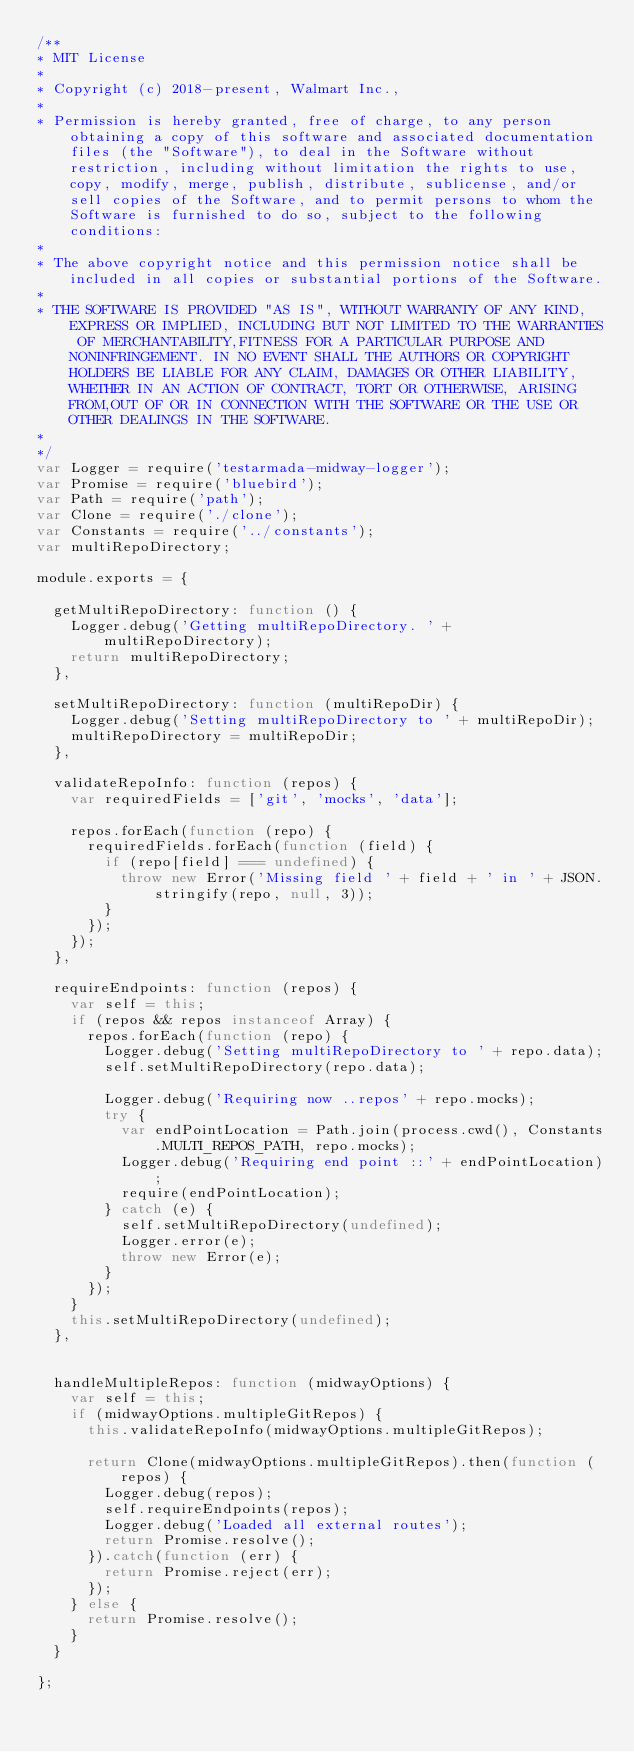Convert code to text. <code><loc_0><loc_0><loc_500><loc_500><_JavaScript_>/**
* MIT License
*
* Copyright (c) 2018-present, Walmart Inc.,
*
* Permission is hereby granted, free of charge, to any person obtaining a copy of this software and associated documentation files (the "Software"), to deal in the Software without restriction, including without limitation the rights to use, copy, modify, merge, publish, distribute, sublicense, and/or sell copies of the Software, and to permit persons to whom the Software is furnished to do so, subject to the following conditions:
*
* The above copyright notice and this permission notice shall be included in all copies or substantial portions of the Software.
*
* THE SOFTWARE IS PROVIDED "AS IS", WITHOUT WARRANTY OF ANY KIND, EXPRESS OR IMPLIED, INCLUDING BUT NOT LIMITED TO THE WARRANTIES OF MERCHANTABILITY,FITNESS FOR A PARTICULAR PURPOSE AND NONINFRINGEMENT. IN NO EVENT SHALL THE AUTHORS OR COPYRIGHT HOLDERS BE LIABLE FOR ANY CLAIM, DAMAGES OR OTHER LIABILITY, WHETHER IN AN ACTION OF CONTRACT, TORT OR OTHERWISE, ARISING FROM,OUT OF OR IN CONNECTION WITH THE SOFTWARE OR THE USE OR OTHER DEALINGS IN THE SOFTWARE.
*
*/
var Logger = require('testarmada-midway-logger');
var Promise = require('bluebird');
var Path = require('path');
var Clone = require('./clone');
var Constants = require('../constants');
var multiRepoDirectory;

module.exports = {

  getMultiRepoDirectory: function () {
    Logger.debug('Getting multiRepoDirectory. ' + multiRepoDirectory);
    return multiRepoDirectory;
  },

  setMultiRepoDirectory: function (multiRepoDir) {
    Logger.debug('Setting multiRepoDirectory to ' + multiRepoDir);
    multiRepoDirectory = multiRepoDir;
  },

  validateRepoInfo: function (repos) {
    var requiredFields = ['git', 'mocks', 'data'];

    repos.forEach(function (repo) {
      requiredFields.forEach(function (field) {
        if (repo[field] === undefined) {
          throw new Error('Missing field ' + field + ' in ' + JSON.stringify(repo, null, 3));
        }
      });
    });
  },

  requireEndpoints: function (repos) {
    var self = this;
    if (repos && repos instanceof Array) {
      repos.forEach(function (repo) {
        Logger.debug('Setting multiRepoDirectory to ' + repo.data);
        self.setMultiRepoDirectory(repo.data);

        Logger.debug('Requiring now ..repos' + repo.mocks);
        try {
          var endPointLocation = Path.join(process.cwd(), Constants.MULTI_REPOS_PATH, repo.mocks);
          Logger.debug('Requiring end point ::' + endPointLocation);
          require(endPointLocation);
        } catch (e) {
          self.setMultiRepoDirectory(undefined);
          Logger.error(e);
          throw new Error(e);
        }
      });
    }
    this.setMultiRepoDirectory(undefined);
  },


  handleMultipleRepos: function (midwayOptions) {
    var self = this;
    if (midwayOptions.multipleGitRepos) {
      this.validateRepoInfo(midwayOptions.multipleGitRepos);

      return Clone(midwayOptions.multipleGitRepos).then(function (repos) {
        Logger.debug(repos);
        self.requireEndpoints(repos);
        Logger.debug('Loaded all external routes');
        return Promise.resolve();
      }).catch(function (err) {
        return Promise.reject(err);
      });
    } else {
      return Promise.resolve();
    }
  }

};
</code> 